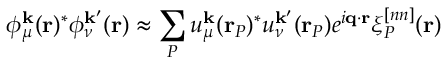Convert formula to latex. <formula><loc_0><loc_0><loc_500><loc_500>\phi _ { \mu } ^ { k } ( r ) ^ { * } \phi _ { \nu } ^ { k ^ { \prime } } ( r ) \approx \sum _ { P } u _ { \mu } ^ { k } ( r _ { P } ) ^ { * } u _ { \nu } ^ { k ^ { \prime } } ( r _ { P } ) e ^ { i q \cdot r } \xi _ { P } ^ { [ n n ] } ( r )</formula> 